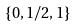Convert formula to latex. <formula><loc_0><loc_0><loc_500><loc_500>\{ 0 , 1 / 2 , 1 \}</formula> 